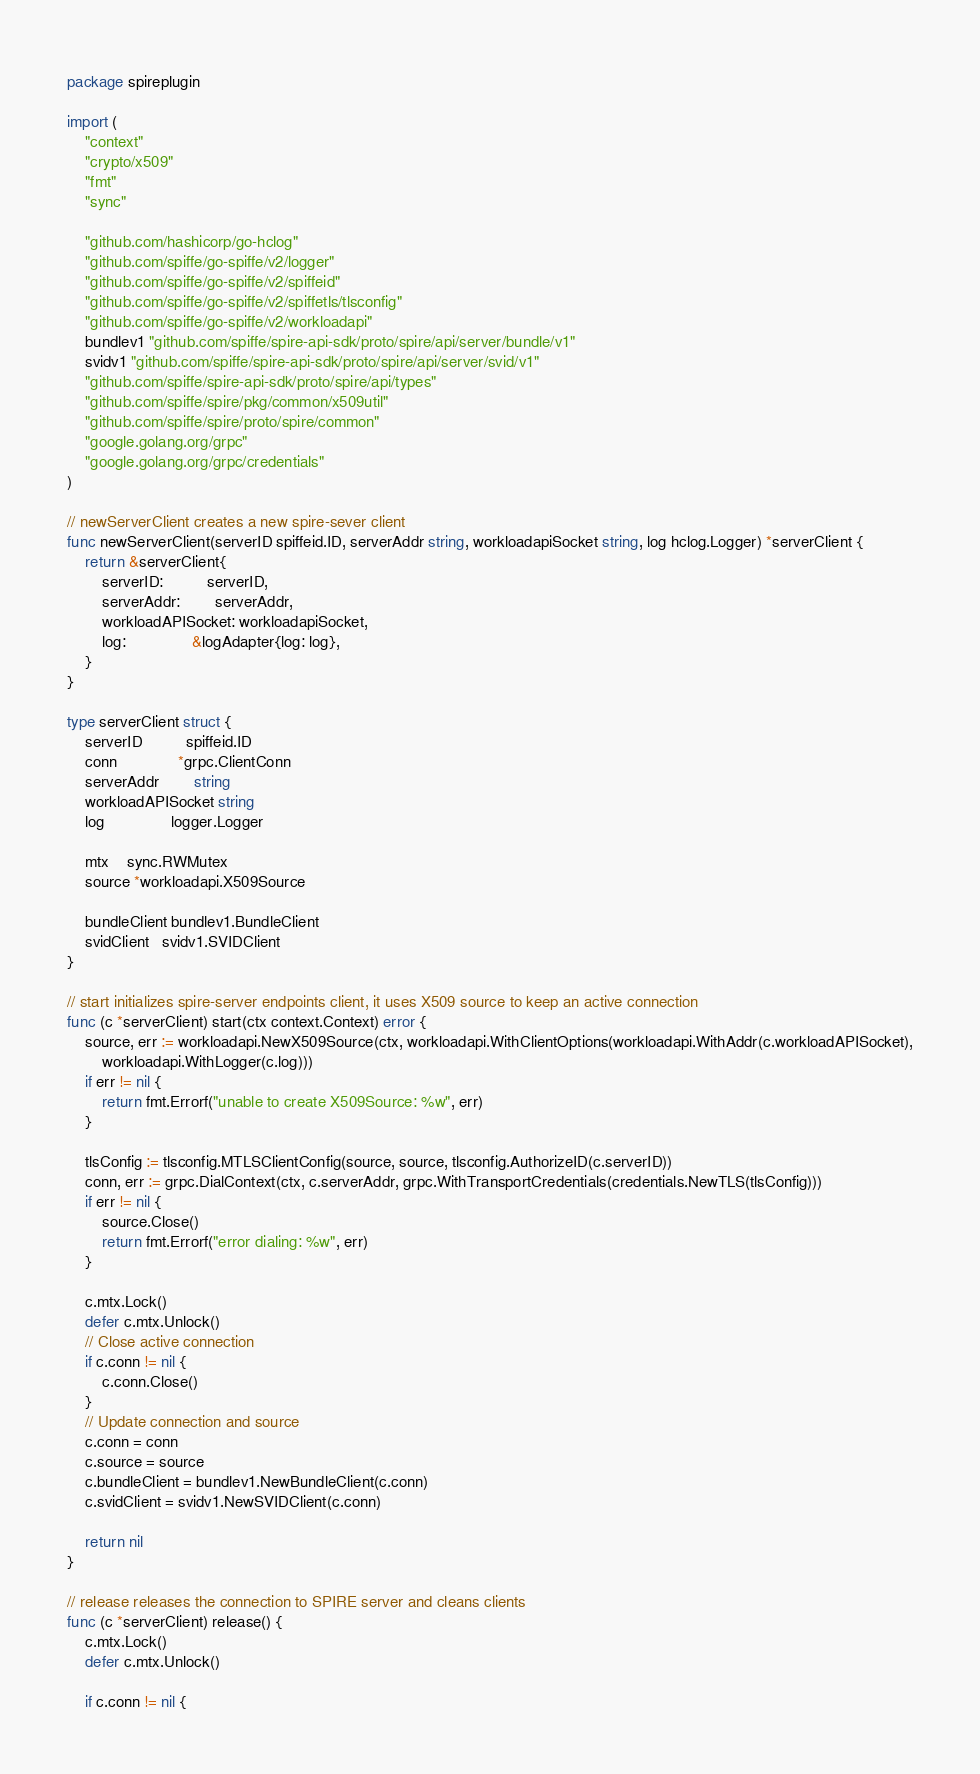<code> <loc_0><loc_0><loc_500><loc_500><_Go_>package spireplugin

import (
	"context"
	"crypto/x509"
	"fmt"
	"sync"

	"github.com/hashicorp/go-hclog"
	"github.com/spiffe/go-spiffe/v2/logger"
	"github.com/spiffe/go-spiffe/v2/spiffeid"
	"github.com/spiffe/go-spiffe/v2/spiffetls/tlsconfig"
	"github.com/spiffe/go-spiffe/v2/workloadapi"
	bundlev1 "github.com/spiffe/spire-api-sdk/proto/spire/api/server/bundle/v1"
	svidv1 "github.com/spiffe/spire-api-sdk/proto/spire/api/server/svid/v1"
	"github.com/spiffe/spire-api-sdk/proto/spire/api/types"
	"github.com/spiffe/spire/pkg/common/x509util"
	"github.com/spiffe/spire/proto/spire/common"
	"google.golang.org/grpc"
	"google.golang.org/grpc/credentials"
)

// newServerClient creates a new spire-sever client
func newServerClient(serverID spiffeid.ID, serverAddr string, workloadapiSocket string, log hclog.Logger) *serverClient {
	return &serverClient{
		serverID:          serverID,
		serverAddr:        serverAddr,
		workloadAPISocket: workloadapiSocket,
		log:               &logAdapter{log: log},
	}
}

type serverClient struct {
	serverID          spiffeid.ID
	conn              *grpc.ClientConn
	serverAddr        string
	workloadAPISocket string
	log               logger.Logger

	mtx    sync.RWMutex
	source *workloadapi.X509Source

	bundleClient bundlev1.BundleClient
	svidClient   svidv1.SVIDClient
}

// start initializes spire-server endpoints client, it uses X509 source to keep an active connection
func (c *serverClient) start(ctx context.Context) error {
	source, err := workloadapi.NewX509Source(ctx, workloadapi.WithClientOptions(workloadapi.WithAddr(c.workloadAPISocket),
		workloadapi.WithLogger(c.log)))
	if err != nil {
		return fmt.Errorf("unable to create X509Source: %w", err)
	}

	tlsConfig := tlsconfig.MTLSClientConfig(source, source, tlsconfig.AuthorizeID(c.serverID))
	conn, err := grpc.DialContext(ctx, c.serverAddr, grpc.WithTransportCredentials(credentials.NewTLS(tlsConfig)))
	if err != nil {
		source.Close()
		return fmt.Errorf("error dialing: %w", err)
	}

	c.mtx.Lock()
	defer c.mtx.Unlock()
	// Close active connection
	if c.conn != nil {
		c.conn.Close()
	}
	// Update connection and source
	c.conn = conn
	c.source = source
	c.bundleClient = bundlev1.NewBundleClient(c.conn)
	c.svidClient = svidv1.NewSVIDClient(c.conn)

	return nil
}

// release releases the connection to SPIRE server and cleans clients
func (c *serverClient) release() {
	c.mtx.Lock()
	defer c.mtx.Unlock()

	if c.conn != nil {</code> 